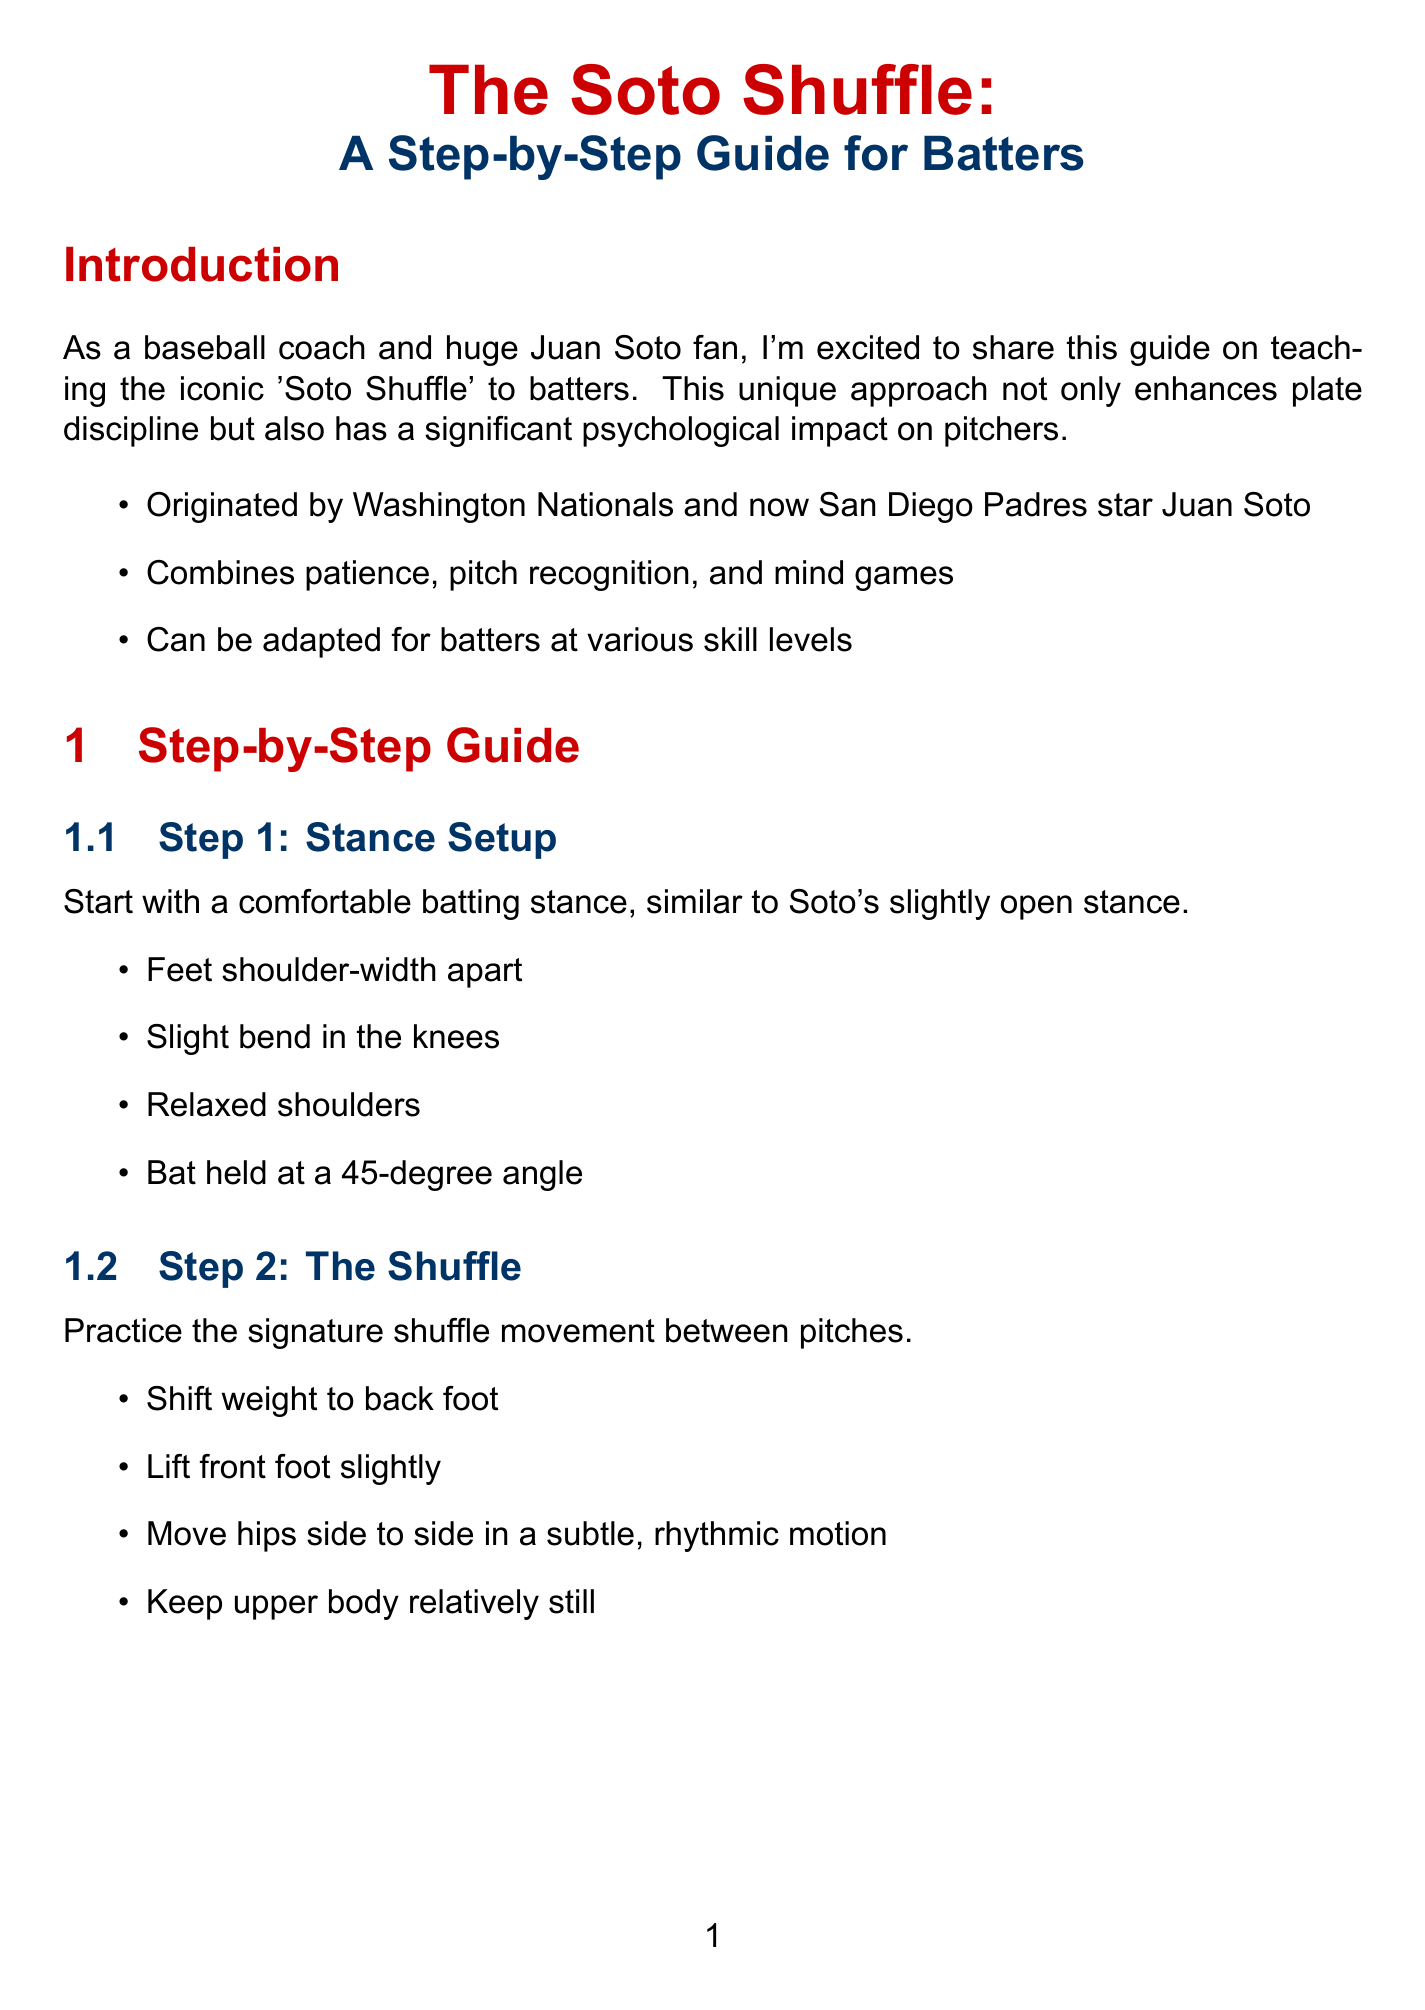what is the title of the document? The title is stated at the beginning of the document, introducing the main subject of the guide.
Answer: The Soto Shuffle: A Step-by-Step Guide for Batters who is the player associated with the Soto Shuffle? The document mentions Juan Soto as the originator of the Soto Shuffle technique.
Answer: Juan Soto what is the first step in teaching the Soto Shuffle? The first step is listed in the step-by-step guide, detailing the initial setup for batters.
Answer: Stance Setup how many key elements are identified for the shuffle itself? The document lists the key elements specifically for the shuffle movement, which are outlined in Step 2.
Answer: Four what is one psychological impact of the Soto Shuffle on pitchers? The document includes several impacts on pitchers, as noted in the psychological impact section.
Answer: Creates uncertainty and disrupts timing how can batters practice pitch recognition? The training drills section describes a specific drill aimed at enhancing this skill.
Answer: Pitch Recognition Shuffle what are batters encouraged to do to personalize the shuffle? The additional tips section advises batters on how to incorporate their individual styles.
Answer: Personalize the shuffle to fit their style what should batters maintain while executing the shuffle? The document highlights an important aspect of the execution, particularly aimed at ensuring mental focus.
Answer: Composure in high-pressure situations 